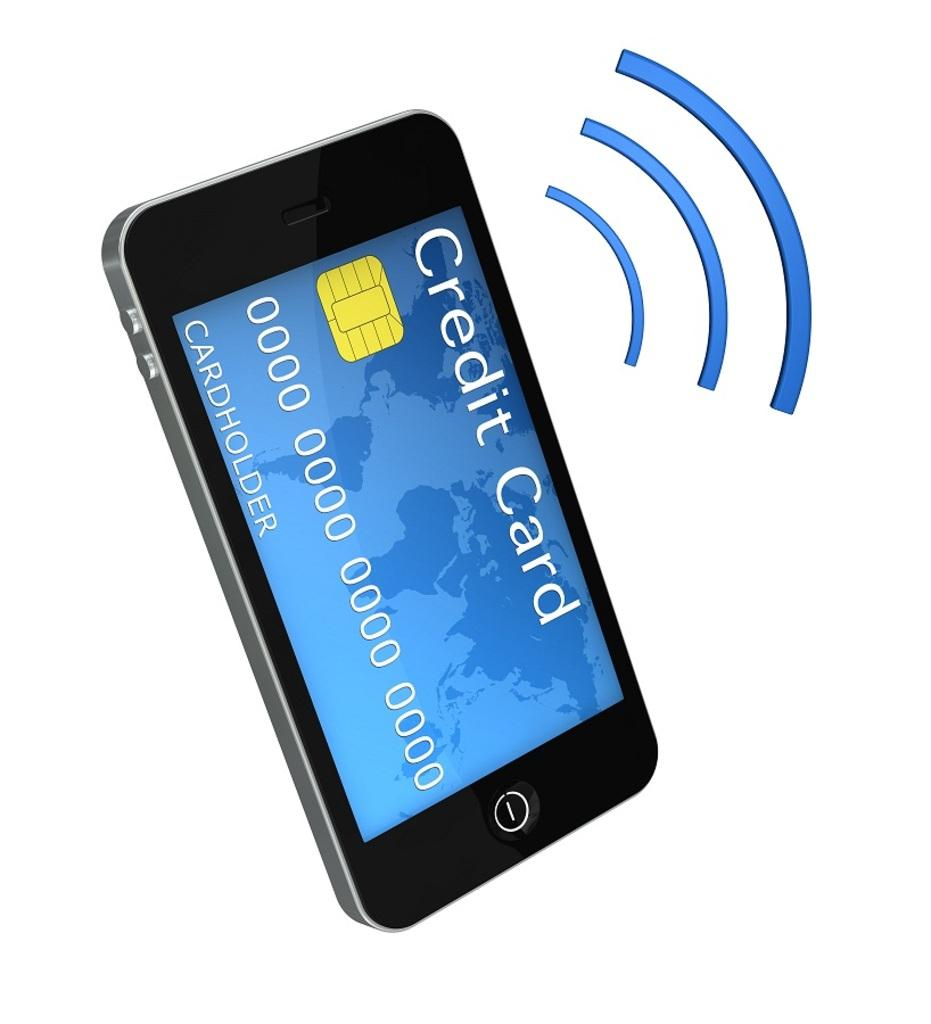<image>
Give a short and clear explanation of the subsequent image. A smart phone that shows a fake credit card on its screen. 